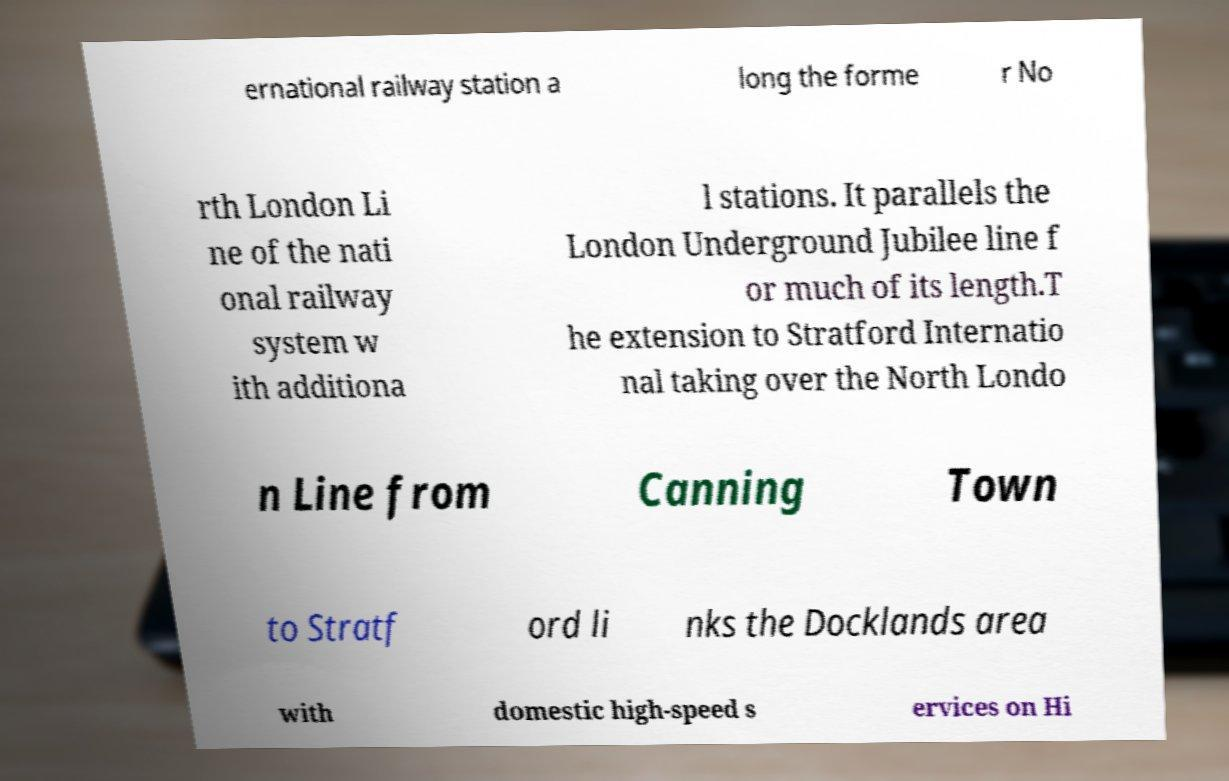I need the written content from this picture converted into text. Can you do that? ernational railway station a long the forme r No rth London Li ne of the nati onal railway system w ith additiona l stations. It parallels the London Underground Jubilee line f or much of its length.T he extension to Stratford Internatio nal taking over the North Londo n Line from Canning Town to Stratf ord li nks the Docklands area with domestic high-speed s ervices on Hi 